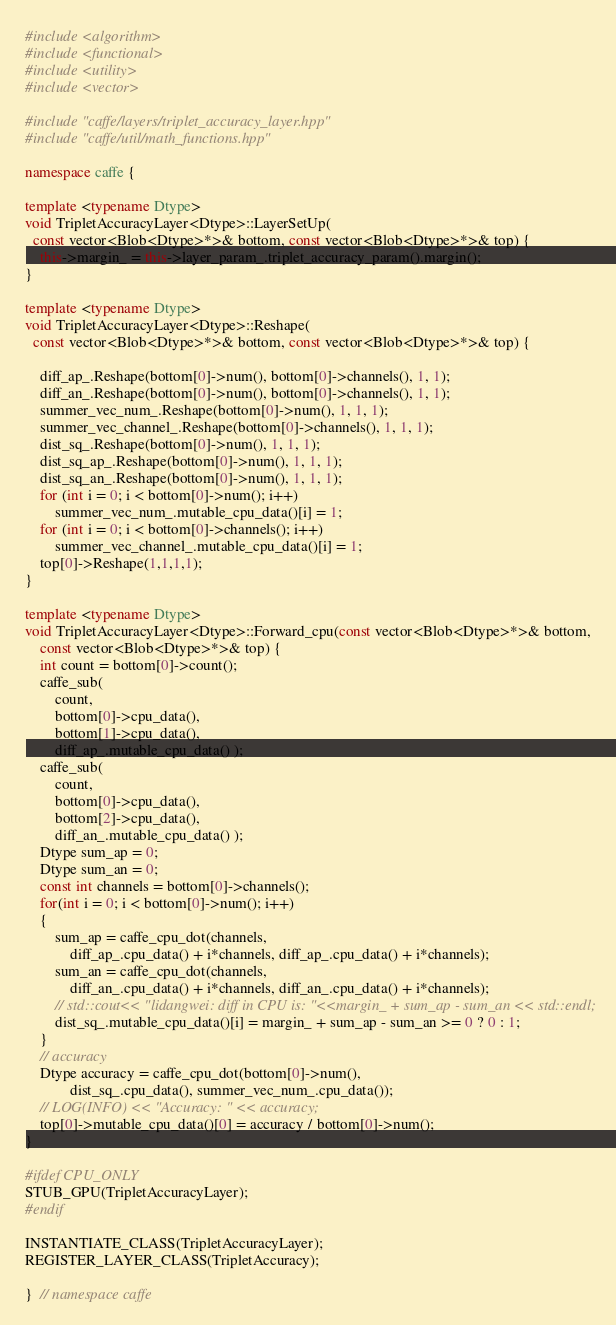<code> <loc_0><loc_0><loc_500><loc_500><_C++_>#include <algorithm>
#include <functional>
#include <utility>
#include <vector>

#include "caffe/layers/triplet_accuracy_layer.hpp"
#include "caffe/util/math_functions.hpp"

namespace caffe {

template <typename Dtype>
void TripletAccuracyLayer<Dtype>::LayerSetUp(
  const vector<Blob<Dtype>*>& bottom, const vector<Blob<Dtype>*>& top) {
    this->margin_ = this->layer_param_.triplet_accuracy_param().margin();
}

template <typename Dtype>
void TripletAccuracyLayer<Dtype>::Reshape(
  const vector<Blob<Dtype>*>& bottom, const vector<Blob<Dtype>*>& top) {

    diff_ap_.Reshape(bottom[0]->num(), bottom[0]->channels(), 1, 1);
    diff_an_.Reshape(bottom[0]->num(), bottom[0]->channels(), 1, 1);
    summer_vec_num_.Reshape(bottom[0]->num(), 1, 1, 1);
    summer_vec_channel_.Reshape(bottom[0]->channels(), 1, 1, 1);
    dist_sq_.Reshape(bottom[0]->num(), 1, 1, 1);
    dist_sq_ap_.Reshape(bottom[0]->num(), 1, 1, 1);
    dist_sq_an_.Reshape(bottom[0]->num(), 1, 1, 1);
    for (int i = 0; i < bottom[0]->num(); i++)
        summer_vec_num_.mutable_cpu_data()[i] = 1;
    for (int i = 0; i < bottom[0]->channels(); i++)
        summer_vec_channel_.mutable_cpu_data()[i] = 1;
    top[0]->Reshape(1,1,1,1);
}

template <typename Dtype>
void TripletAccuracyLayer<Dtype>::Forward_cpu(const vector<Blob<Dtype>*>& bottom,
    const vector<Blob<Dtype>*>& top) {
    int count = bottom[0]->count();
    caffe_sub(
        count, 
        bottom[0]->cpu_data(),
        bottom[1]->cpu_data(),
        diff_ap_.mutable_cpu_data() );
    caffe_sub(
        count,
        bottom[0]->cpu_data(),
        bottom[2]->cpu_data(),
        diff_an_.mutable_cpu_data() );
    Dtype sum_ap = 0;
    Dtype sum_an = 0;
    const int channels = bottom[0]->channels();
    for(int i = 0; i < bottom[0]->num(); i++)
    {
        sum_ap = caffe_cpu_dot(channels,
            diff_ap_.cpu_data() + i*channels, diff_ap_.cpu_data() + i*channels);
        sum_an = caffe_cpu_dot(channels,
            diff_an_.cpu_data() + i*channels, diff_an_.cpu_data() + i*channels);
        // std::cout<< "lidangwei: diff in CPU is: "<<margin_ + sum_ap - sum_an << std::endl;
        dist_sq_.mutable_cpu_data()[i] = margin_ + sum_ap - sum_an >= 0 ? 0 : 1;
    }
    // accuracy
    Dtype accuracy = caffe_cpu_dot(bottom[0]->num(),
            dist_sq_.cpu_data(), summer_vec_num_.cpu_data());
    // LOG(INFO) << "Accuracy: " << accuracy;
    top[0]->mutable_cpu_data()[0] = accuracy / bottom[0]->num();
}

#ifdef CPU_ONLY
STUB_GPU(TripletAccuracyLayer);
#endif

INSTANTIATE_CLASS(TripletAccuracyLayer);
REGISTER_LAYER_CLASS(TripletAccuracy);

}  // namespace caffe
</code> 